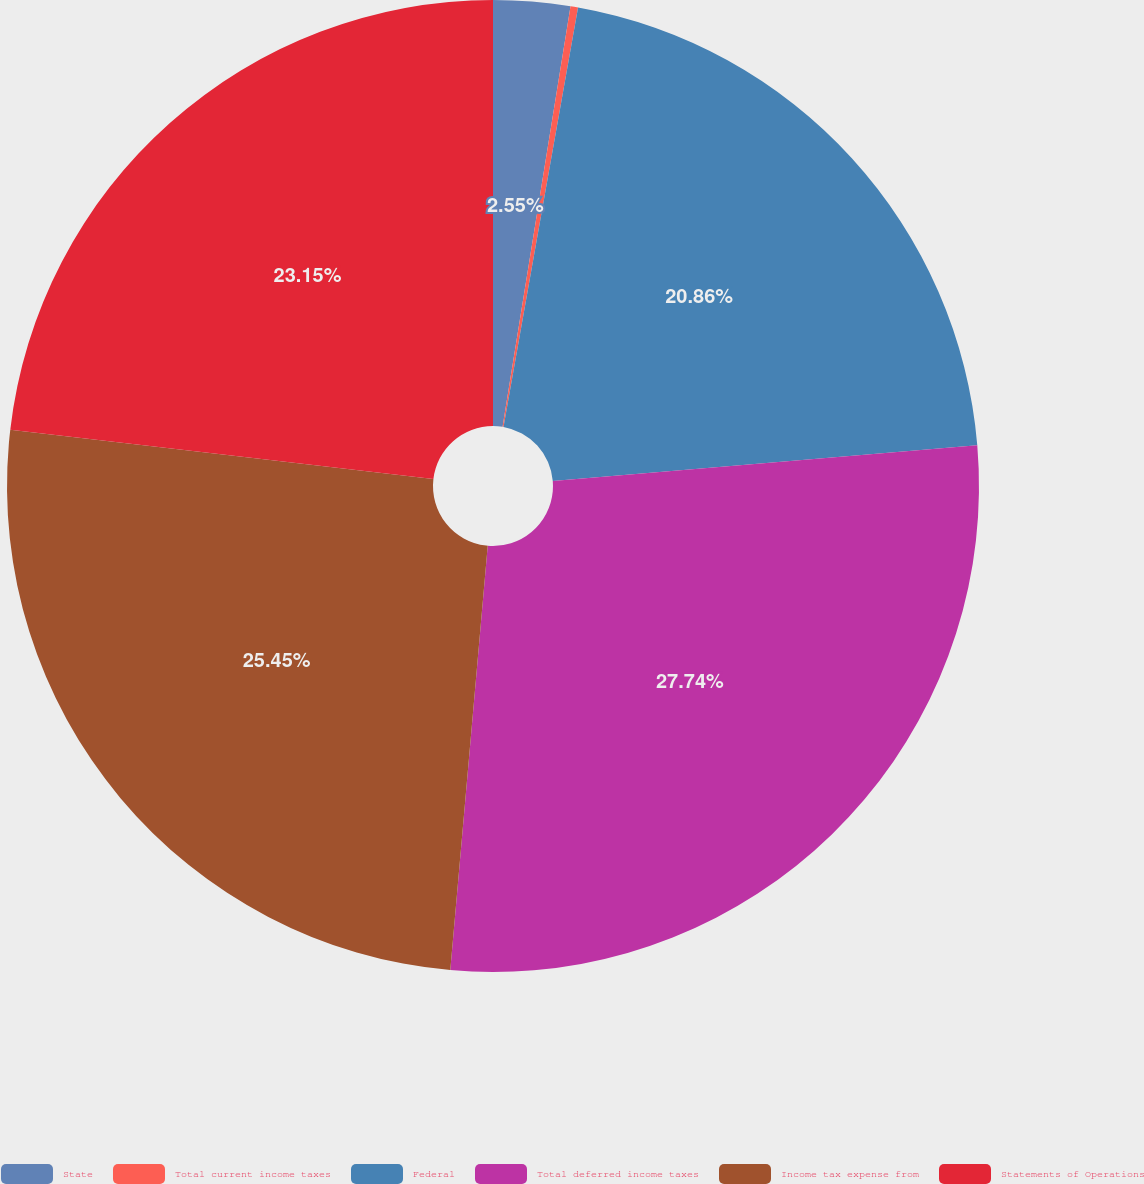<chart> <loc_0><loc_0><loc_500><loc_500><pie_chart><fcel>State<fcel>Total current income taxes<fcel>Federal<fcel>Total deferred income taxes<fcel>Income tax expense from<fcel>Statements of Operations<nl><fcel>2.55%<fcel>0.25%<fcel>20.86%<fcel>27.74%<fcel>25.45%<fcel>23.15%<nl></chart> 